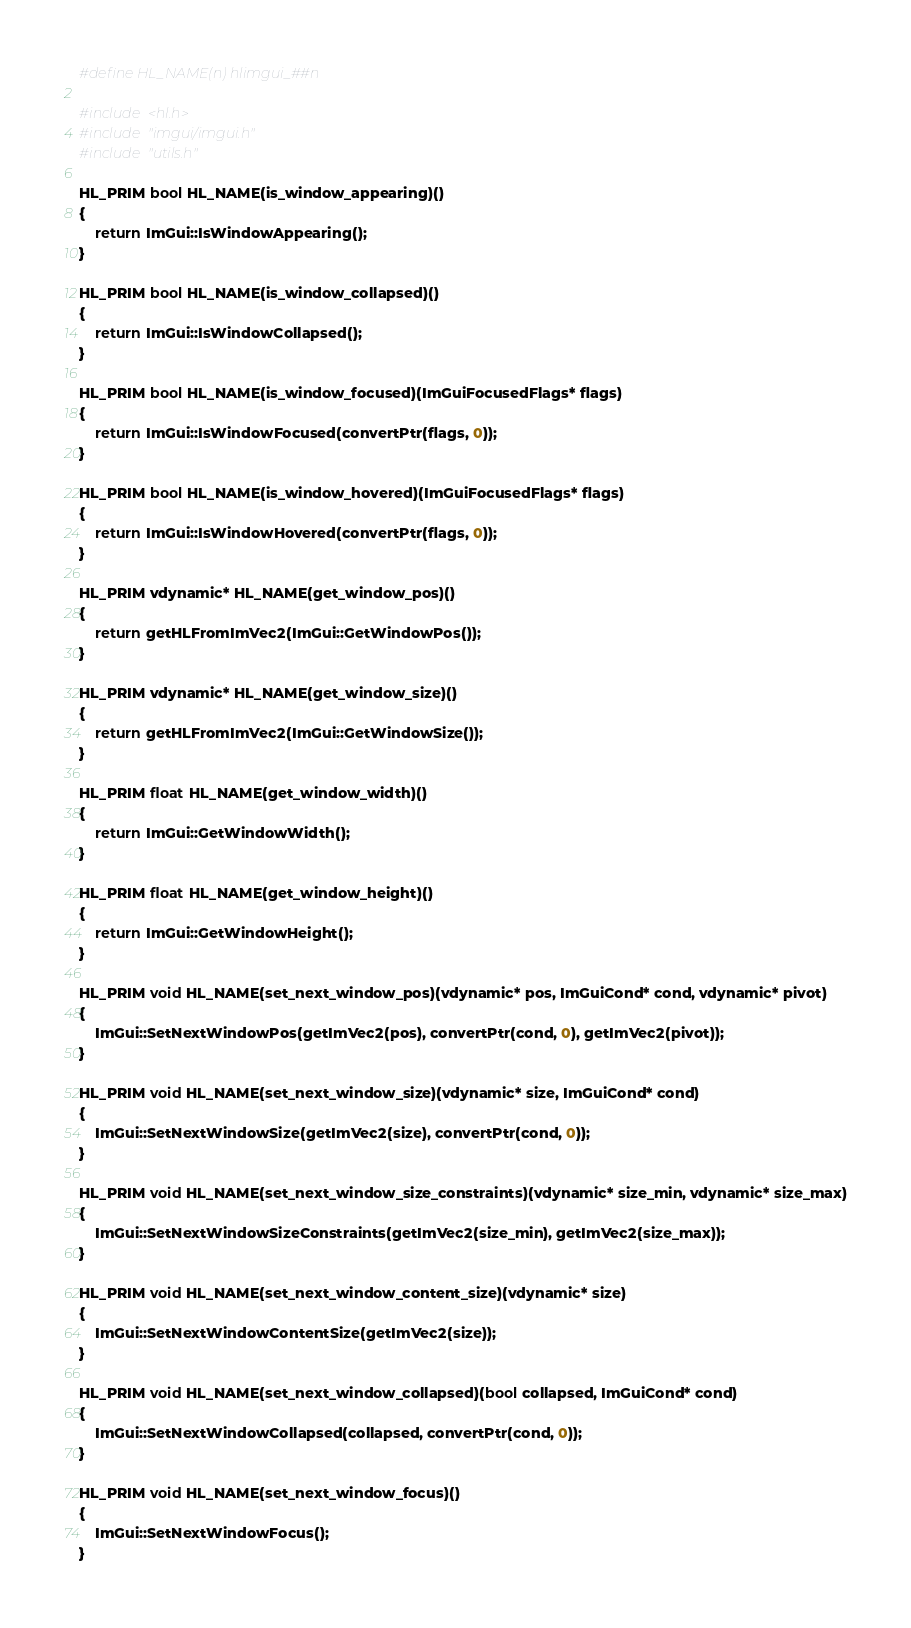Convert code to text. <code><loc_0><loc_0><loc_500><loc_500><_C++_>#define HL_NAME(n) hlimgui_##n

#include <hl.h>
#include "imgui/imgui.h"
#include "utils.h"

HL_PRIM bool HL_NAME(is_window_appearing)()
{
	return ImGui::IsWindowAppearing();
}

HL_PRIM bool HL_NAME(is_window_collapsed)()
{
	return ImGui::IsWindowCollapsed();
}

HL_PRIM bool HL_NAME(is_window_focused)(ImGuiFocusedFlags* flags)
{
	return ImGui::IsWindowFocused(convertPtr(flags, 0));
}

HL_PRIM bool HL_NAME(is_window_hovered)(ImGuiFocusedFlags* flags)
{
	return ImGui::IsWindowHovered(convertPtr(flags, 0));
}

HL_PRIM vdynamic* HL_NAME(get_window_pos)()
{
	return getHLFromImVec2(ImGui::GetWindowPos());
}

HL_PRIM vdynamic* HL_NAME(get_window_size)()
{
	return getHLFromImVec2(ImGui::GetWindowSize());
}

HL_PRIM float HL_NAME(get_window_width)()
{
	return ImGui::GetWindowWidth();
}

HL_PRIM float HL_NAME(get_window_height)()
{
	return ImGui::GetWindowHeight();
}

HL_PRIM void HL_NAME(set_next_window_pos)(vdynamic* pos, ImGuiCond* cond, vdynamic* pivot)
{
	ImGui::SetNextWindowPos(getImVec2(pos), convertPtr(cond, 0), getImVec2(pivot));
}

HL_PRIM void HL_NAME(set_next_window_size)(vdynamic* size, ImGuiCond* cond)
{
	ImGui::SetNextWindowSize(getImVec2(size), convertPtr(cond, 0));
}

HL_PRIM void HL_NAME(set_next_window_size_constraints)(vdynamic* size_min, vdynamic* size_max)
{
	ImGui::SetNextWindowSizeConstraints(getImVec2(size_min), getImVec2(size_max));
}

HL_PRIM void HL_NAME(set_next_window_content_size)(vdynamic* size)
{
	ImGui::SetNextWindowContentSize(getImVec2(size));
}

HL_PRIM void HL_NAME(set_next_window_collapsed)(bool collapsed, ImGuiCond* cond)
{
	ImGui::SetNextWindowCollapsed(collapsed, convertPtr(cond, 0));
}

HL_PRIM void HL_NAME(set_next_window_focus)()
{
	ImGui::SetNextWindowFocus();
}
</code> 